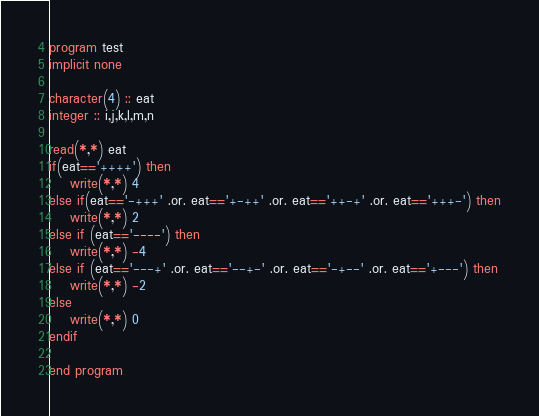<code> <loc_0><loc_0><loc_500><loc_500><_FORTRAN_>program test
implicit none

character(4) :: eat
integer :: i,j,k,l,m,n

read(*,*) eat
if(eat=='++++') then
	write(*,*) 4
else if(eat=='-+++' .or. eat=='+-++' .or. eat=='++-+' .or. eat=='+++-') then
	write(*,*) 2
else if (eat=='----') then
	write(*,*) -4
else if (eat=='---+' .or. eat=='--+-' .or. eat=='-+--' .or. eat=='+---') then
	write(*,*) -2
else
	write(*,*) 0
endif

end program</code> 